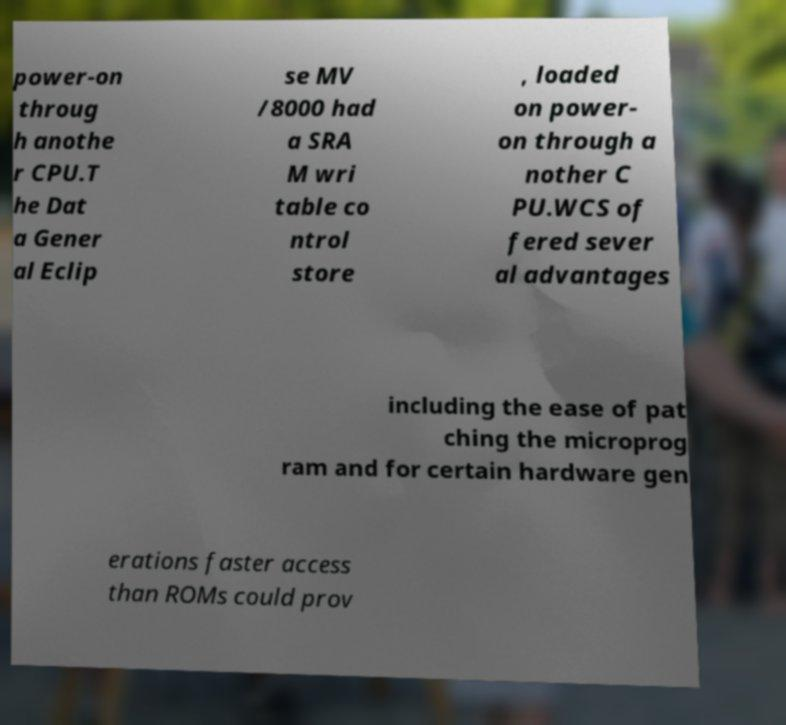Could you extract and type out the text from this image? power-on throug h anothe r CPU.T he Dat a Gener al Eclip se MV /8000 had a SRA M wri table co ntrol store , loaded on power- on through a nother C PU.WCS of fered sever al advantages including the ease of pat ching the microprog ram and for certain hardware gen erations faster access than ROMs could prov 